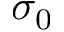Convert formula to latex. <formula><loc_0><loc_0><loc_500><loc_500>\sigma _ { 0 }</formula> 